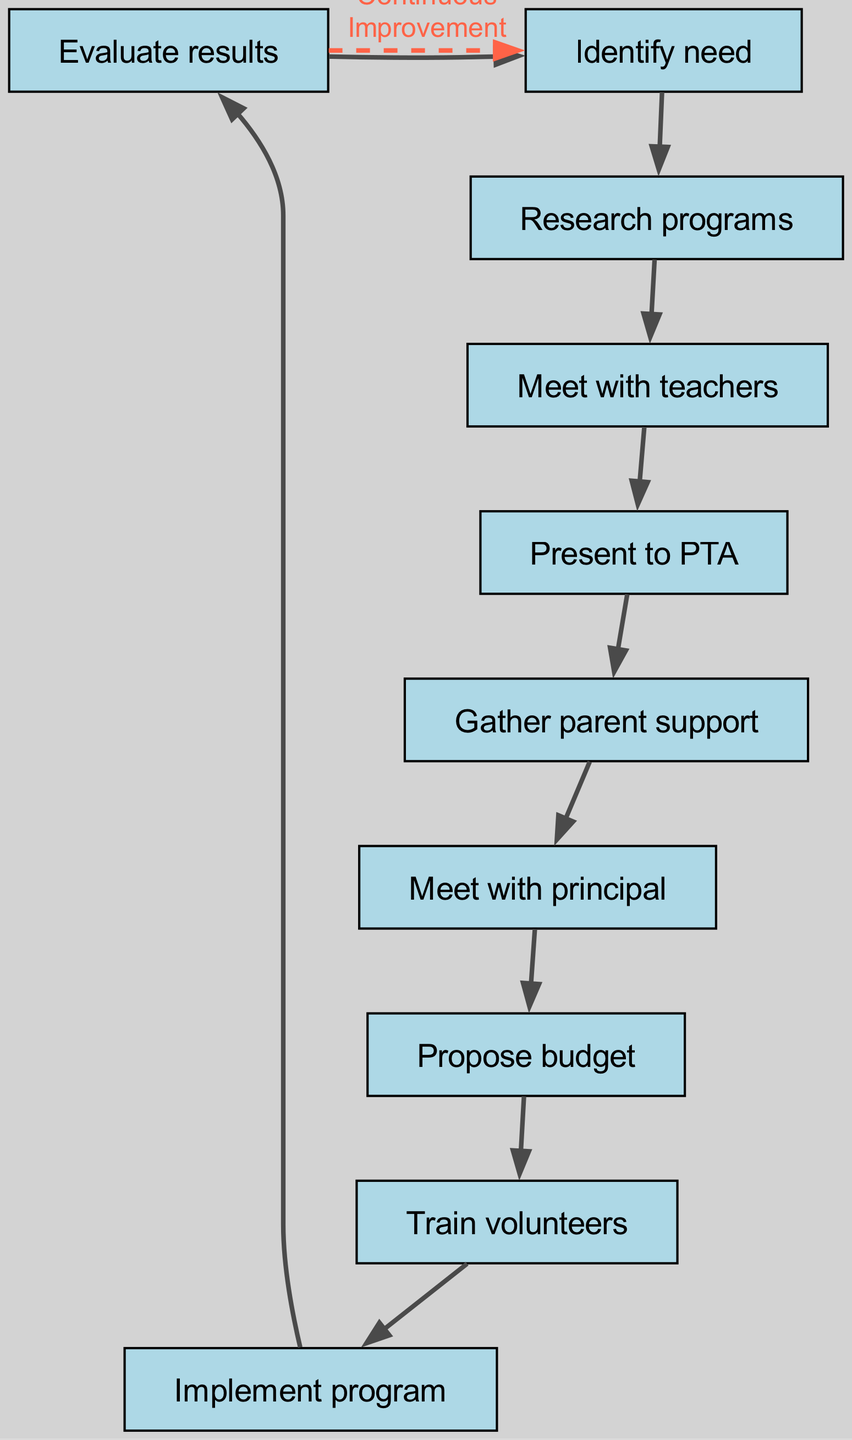What is the first step in the process? The first step is "Identify need," which is the starting point and appears at the top of the directed graph.
Answer: Identify need How many nodes are there in total? There are 10 distinct nodes represented in the directed graph, each describing a step in the process.
Answer: 10 What needs to happen before the budget proposal? Before proposing a budget, one must meet with the principal. This relationship is depicted as a directed edge going from "Meet with principal" to "Propose budget."
Answer: Meet with principal Which node comes after "Gather parent support"? The node that follows "Gather parent support" is "Meet with principal," indicating that parent support leads to a meeting with the school principal.
Answer: Meet with principal What is the relationship between "Evaluate results" and "Identify need"? "Evaluate results" leads back to "Identify need," indicating a loop or cycle that represents continuous improvement in the program based on the evaluation.
Answer: Continuous Improvement What is the last step in the process depicted in the graph? The last step in the process is "Evaluate results," which completes the cycle of the reading program implementation.
Answer: Evaluate results How many edges are there between the nodes? The directed graph contains 10 edges that connect the various steps in the reading program advocacy and implementation process.
Answer: 10 What is the main purpose of the node "Train volunteers"? The main purpose of the node "Train volunteers" is to prepare individuals who will assist in implementing the program, serving as a crucial step after budget proposal.
Answer: Prepare individuals Which step directly follows "Implement program"? The step that directly follows "Implement program" is "Evaluate results," indicating that after implementation, the results need to be assessed.
Answer: Evaluate results 